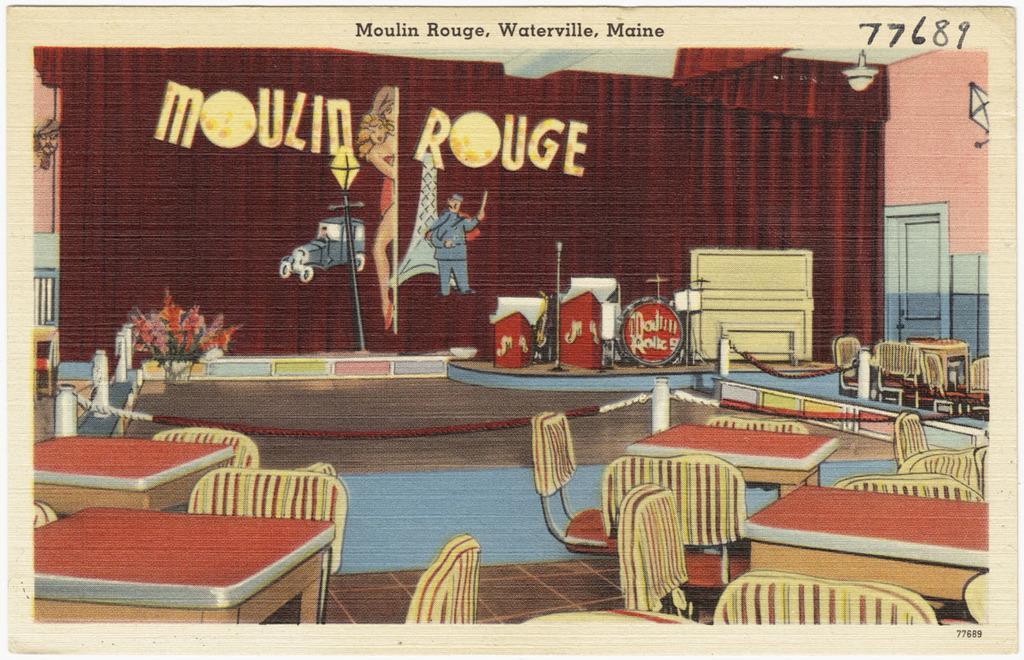Could you give a brief overview of what you see in this image? In this picture we can see tables, chairs, flower bouquet, chain, rods, and musical instruments. There is a mike and this is curtain. This is floor and there is a fan. There is a door and this is wall. 